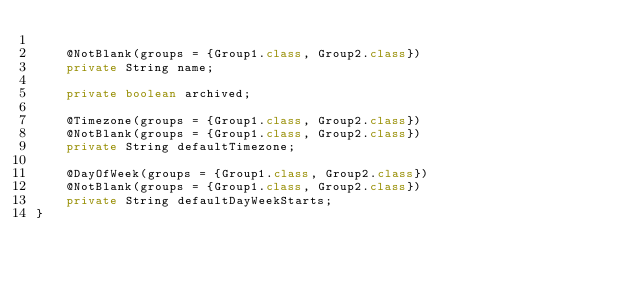Convert code to text. <code><loc_0><loc_0><loc_500><loc_500><_Java_>
    @NotBlank(groups = {Group1.class, Group2.class})
    private String name;

    private boolean archived;

    @Timezone(groups = {Group1.class, Group2.class})
    @NotBlank(groups = {Group1.class, Group2.class})
    private String defaultTimezone;

    @DayOfWeek(groups = {Group1.class, Group2.class})
    @NotBlank(groups = {Group1.class, Group2.class})
    private String defaultDayWeekStarts;
}
</code> 